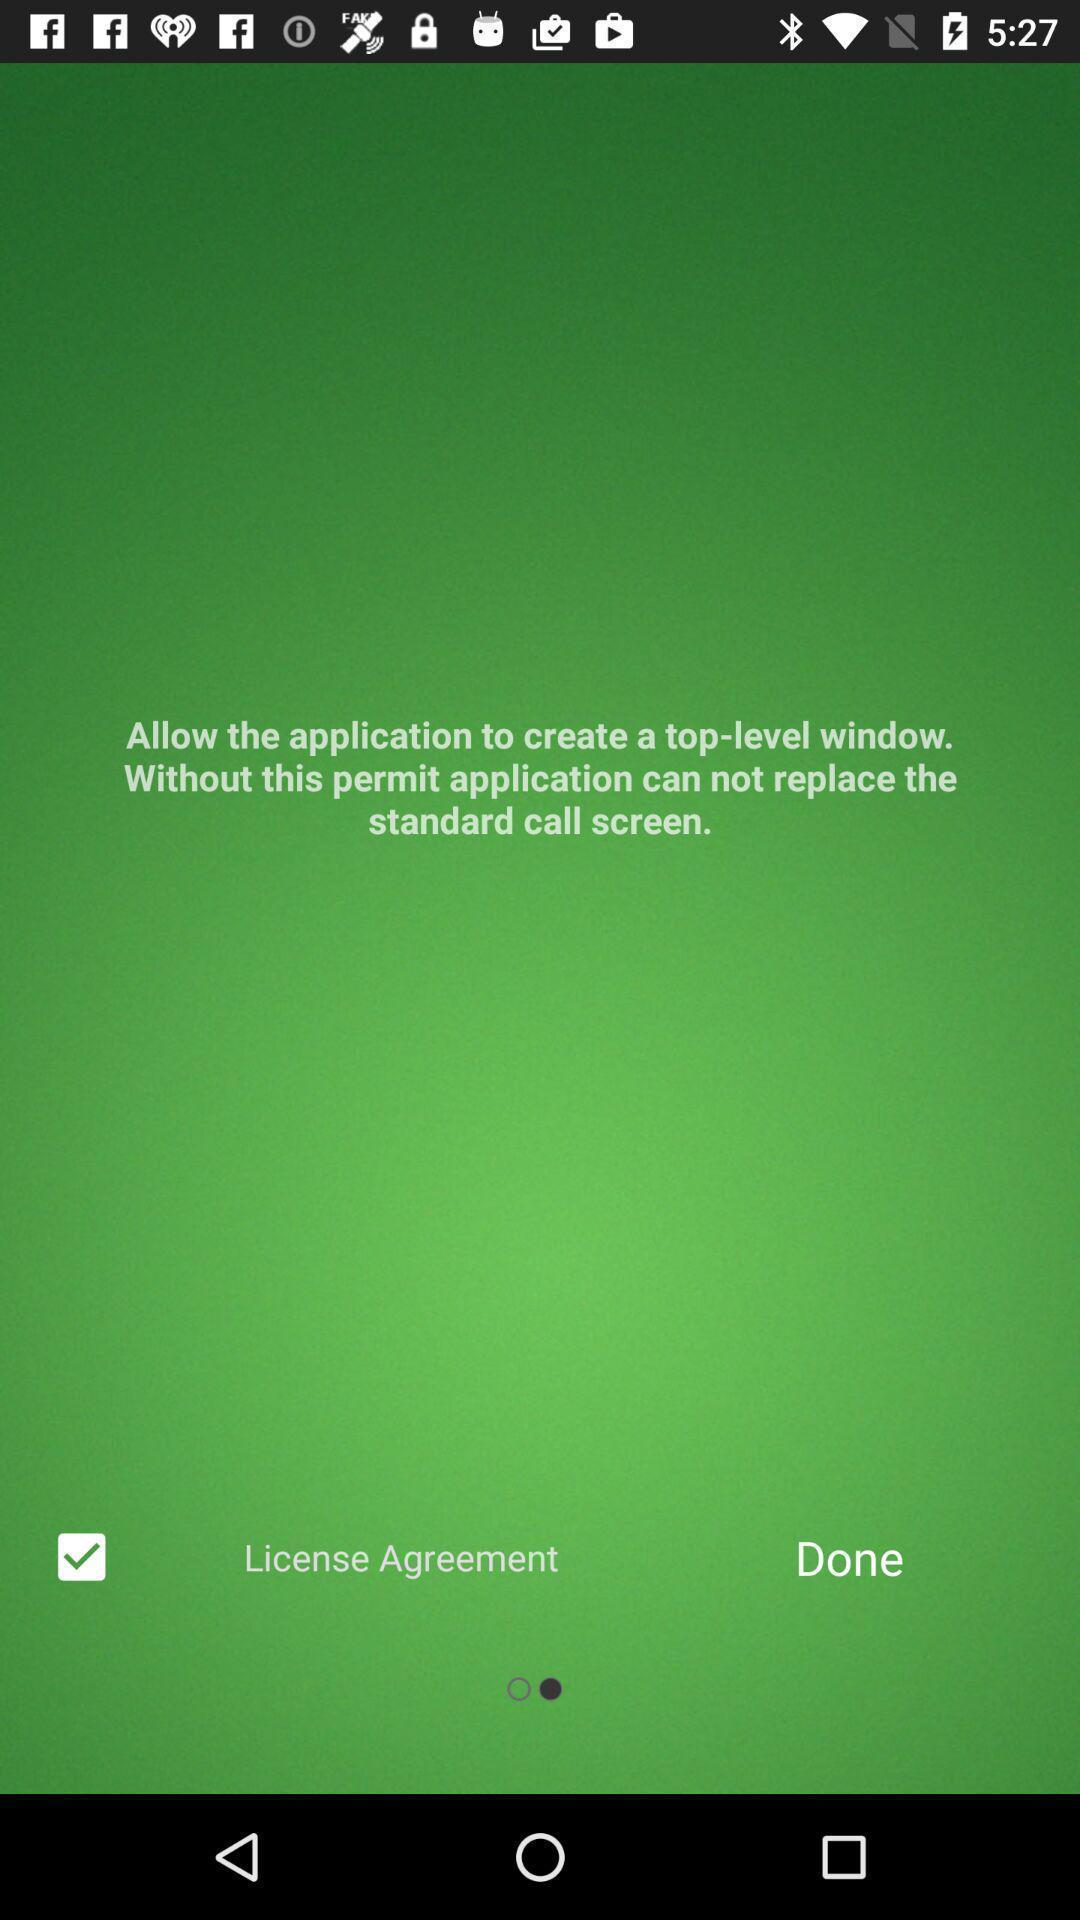Describe the visual elements of this screenshot. Welcome page of a call logs app. 